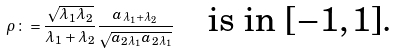Convert formula to latex. <formula><loc_0><loc_0><loc_500><loc_500>\rho \colon = \frac { \sqrt { \lambda _ { 1 } \lambda _ { 2 } } } { \lambda _ { 1 } + \lambda _ { 2 } } \frac { a _ { \lambda _ { 1 } + \lambda _ { 2 } } } { \sqrt { a _ { 2 \lambda _ { 1 } } a _ { 2 \lambda _ { 1 } } } } \quad \text {is in $[-1,1]$.}</formula> 